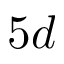<formula> <loc_0><loc_0><loc_500><loc_500>5 d</formula> 